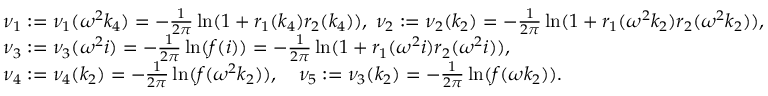<formula> <loc_0><loc_0><loc_500><loc_500>\begin{array} { r l } & { \nu _ { 1 } \colon = \nu _ { 1 } ( \omega ^ { 2 } k _ { 4 } ) = - \frac { 1 } { 2 \pi } \ln ( 1 + r _ { 1 } ( k _ { 4 } ) r _ { 2 } ( k _ { 4 } ) ) , \, \nu _ { 2 } \colon = \nu _ { 2 } ( k _ { 2 } ) = - \frac { 1 } { 2 \pi } \ln ( 1 + r _ { 1 } ( \omega ^ { 2 } k _ { 2 } ) r _ { 2 } ( \omega ^ { 2 } k _ { 2 } ) ) , } \\ & { \nu _ { 3 } \colon = \nu _ { 3 } ( \omega ^ { 2 } i ) = - \frac { 1 } { 2 \pi } \ln ( f ( i ) ) = - \frac { 1 } { 2 \pi } \ln ( 1 + r _ { 1 } ( \omega ^ { 2 } i ) r _ { 2 } ( \omega ^ { 2 } i ) ) , } \\ & { \nu _ { 4 } \colon = \nu _ { 4 } ( k _ { 2 } ) = - \frac { 1 } { 2 \pi } \ln ( f ( \omega ^ { 2 } k _ { 2 } ) ) , \quad \nu _ { 5 } \colon = \nu _ { 3 } ( k _ { 2 } ) = - \frac { 1 } { 2 \pi } \ln ( f ( \omega k _ { 2 } ) ) . } \end{array}</formula> 